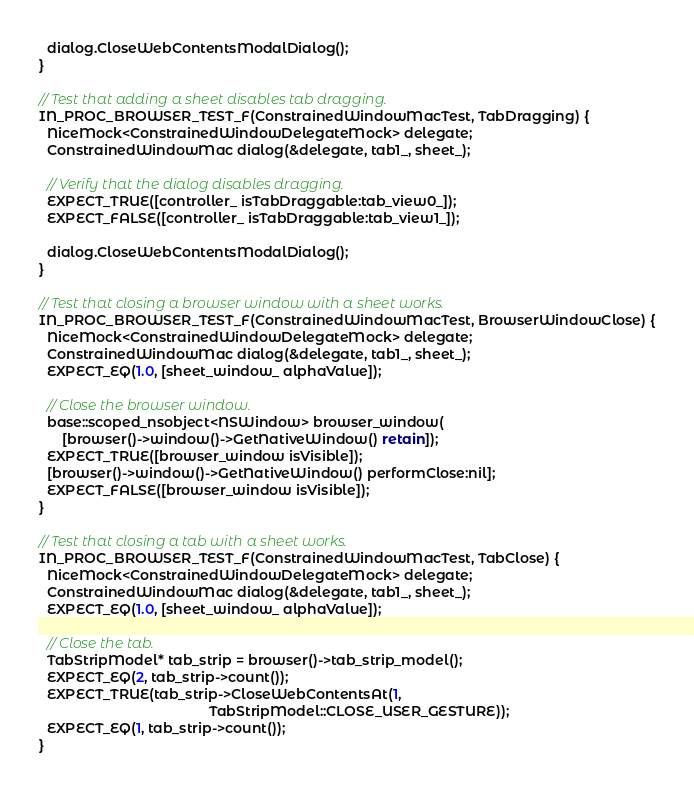<code> <loc_0><loc_0><loc_500><loc_500><_ObjectiveC_>  dialog.CloseWebContentsModalDialog();
}

// Test that adding a sheet disables tab dragging.
IN_PROC_BROWSER_TEST_F(ConstrainedWindowMacTest, TabDragging) {
  NiceMock<ConstrainedWindowDelegateMock> delegate;
  ConstrainedWindowMac dialog(&delegate, tab1_, sheet_);

  // Verify that the dialog disables dragging.
  EXPECT_TRUE([controller_ isTabDraggable:tab_view0_]);
  EXPECT_FALSE([controller_ isTabDraggable:tab_view1_]);

  dialog.CloseWebContentsModalDialog();
}

// Test that closing a browser window with a sheet works.
IN_PROC_BROWSER_TEST_F(ConstrainedWindowMacTest, BrowserWindowClose) {
  NiceMock<ConstrainedWindowDelegateMock> delegate;
  ConstrainedWindowMac dialog(&delegate, tab1_, sheet_);
  EXPECT_EQ(1.0, [sheet_window_ alphaValue]);

  // Close the browser window.
  base::scoped_nsobject<NSWindow> browser_window(
      [browser()->window()->GetNativeWindow() retain]);
  EXPECT_TRUE([browser_window isVisible]);
  [browser()->window()->GetNativeWindow() performClose:nil];
  EXPECT_FALSE([browser_window isVisible]);
}

// Test that closing a tab with a sheet works.
IN_PROC_BROWSER_TEST_F(ConstrainedWindowMacTest, TabClose) {
  NiceMock<ConstrainedWindowDelegateMock> delegate;
  ConstrainedWindowMac dialog(&delegate, tab1_, sheet_);
  EXPECT_EQ(1.0, [sheet_window_ alphaValue]);

  // Close the tab.
  TabStripModel* tab_strip = browser()->tab_strip_model();
  EXPECT_EQ(2, tab_strip->count());
  EXPECT_TRUE(tab_strip->CloseWebContentsAt(1,
                                            TabStripModel::CLOSE_USER_GESTURE));
  EXPECT_EQ(1, tab_strip->count());
}
</code> 